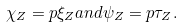<formula> <loc_0><loc_0><loc_500><loc_500>\chi _ { Z } = p \xi _ { Z } a n d \psi _ { Z } = p \tau _ { Z } .</formula> 